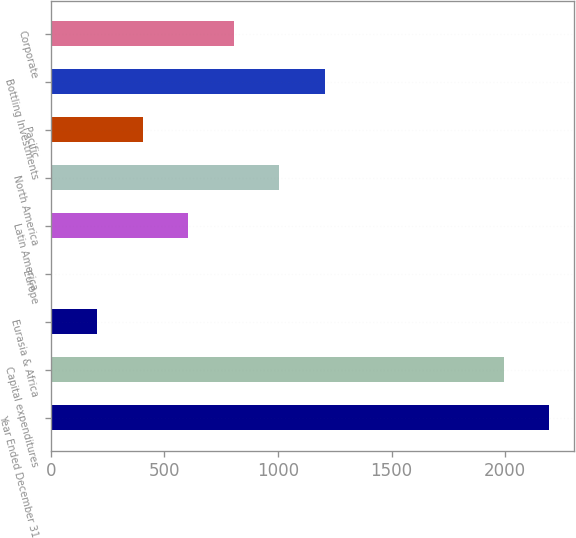Convert chart to OTSL. <chart><loc_0><loc_0><loc_500><loc_500><bar_chart><fcel>Year Ended December 31<fcel>Capital expenditures<fcel>Eurasia & Africa<fcel>Europe<fcel>Latin America<fcel>North America<fcel>Pacific<fcel>Bottling Investments<fcel>Corporate<nl><fcel>2193.56<fcel>1993<fcel>203.96<fcel>3.4<fcel>605.08<fcel>1006.2<fcel>404.52<fcel>1206.76<fcel>805.64<nl></chart> 